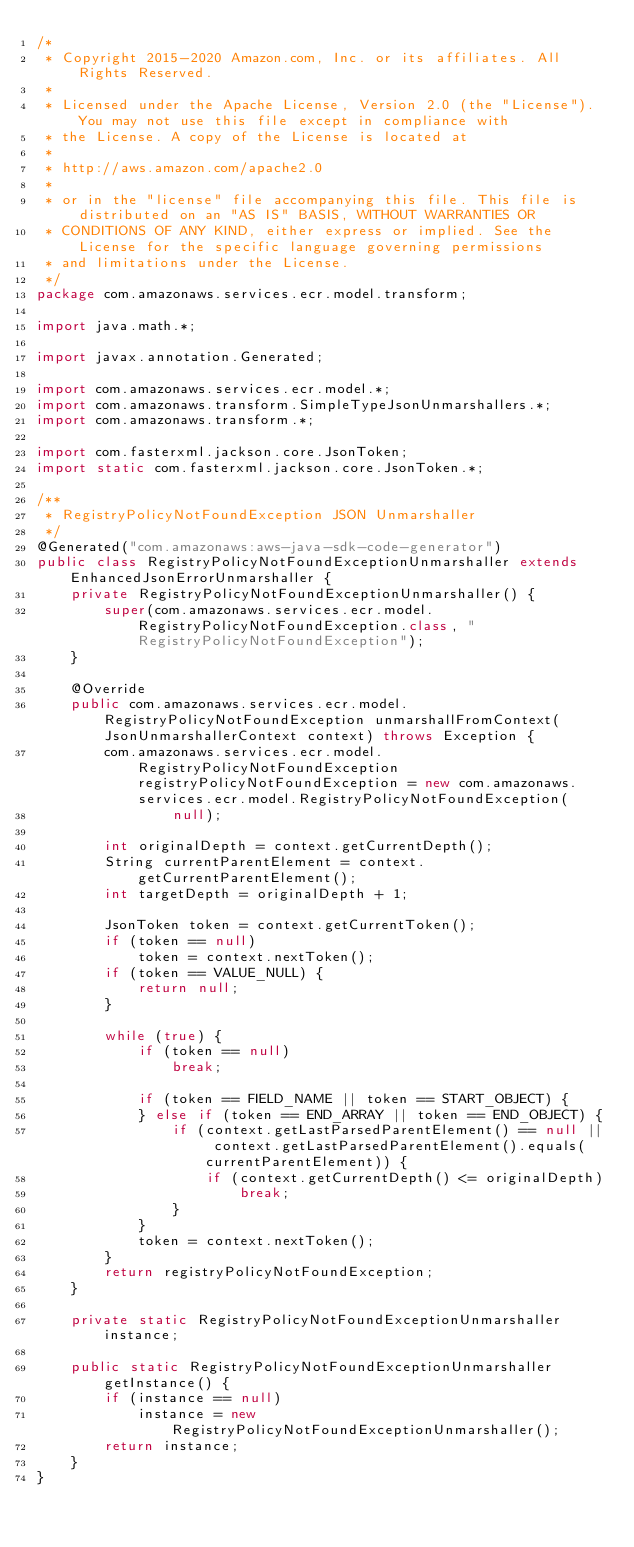<code> <loc_0><loc_0><loc_500><loc_500><_Java_>/*
 * Copyright 2015-2020 Amazon.com, Inc. or its affiliates. All Rights Reserved.
 * 
 * Licensed under the Apache License, Version 2.0 (the "License"). You may not use this file except in compliance with
 * the License. A copy of the License is located at
 * 
 * http://aws.amazon.com/apache2.0
 * 
 * or in the "license" file accompanying this file. This file is distributed on an "AS IS" BASIS, WITHOUT WARRANTIES OR
 * CONDITIONS OF ANY KIND, either express or implied. See the License for the specific language governing permissions
 * and limitations under the License.
 */
package com.amazonaws.services.ecr.model.transform;

import java.math.*;

import javax.annotation.Generated;

import com.amazonaws.services.ecr.model.*;
import com.amazonaws.transform.SimpleTypeJsonUnmarshallers.*;
import com.amazonaws.transform.*;

import com.fasterxml.jackson.core.JsonToken;
import static com.fasterxml.jackson.core.JsonToken.*;

/**
 * RegistryPolicyNotFoundException JSON Unmarshaller
 */
@Generated("com.amazonaws:aws-java-sdk-code-generator")
public class RegistryPolicyNotFoundExceptionUnmarshaller extends EnhancedJsonErrorUnmarshaller {
    private RegistryPolicyNotFoundExceptionUnmarshaller() {
        super(com.amazonaws.services.ecr.model.RegistryPolicyNotFoundException.class, "RegistryPolicyNotFoundException");
    }

    @Override
    public com.amazonaws.services.ecr.model.RegistryPolicyNotFoundException unmarshallFromContext(JsonUnmarshallerContext context) throws Exception {
        com.amazonaws.services.ecr.model.RegistryPolicyNotFoundException registryPolicyNotFoundException = new com.amazonaws.services.ecr.model.RegistryPolicyNotFoundException(
                null);

        int originalDepth = context.getCurrentDepth();
        String currentParentElement = context.getCurrentParentElement();
        int targetDepth = originalDepth + 1;

        JsonToken token = context.getCurrentToken();
        if (token == null)
            token = context.nextToken();
        if (token == VALUE_NULL) {
            return null;
        }

        while (true) {
            if (token == null)
                break;

            if (token == FIELD_NAME || token == START_OBJECT) {
            } else if (token == END_ARRAY || token == END_OBJECT) {
                if (context.getLastParsedParentElement() == null || context.getLastParsedParentElement().equals(currentParentElement)) {
                    if (context.getCurrentDepth() <= originalDepth)
                        break;
                }
            }
            token = context.nextToken();
        }
        return registryPolicyNotFoundException;
    }

    private static RegistryPolicyNotFoundExceptionUnmarshaller instance;

    public static RegistryPolicyNotFoundExceptionUnmarshaller getInstance() {
        if (instance == null)
            instance = new RegistryPolicyNotFoundExceptionUnmarshaller();
        return instance;
    }
}
</code> 